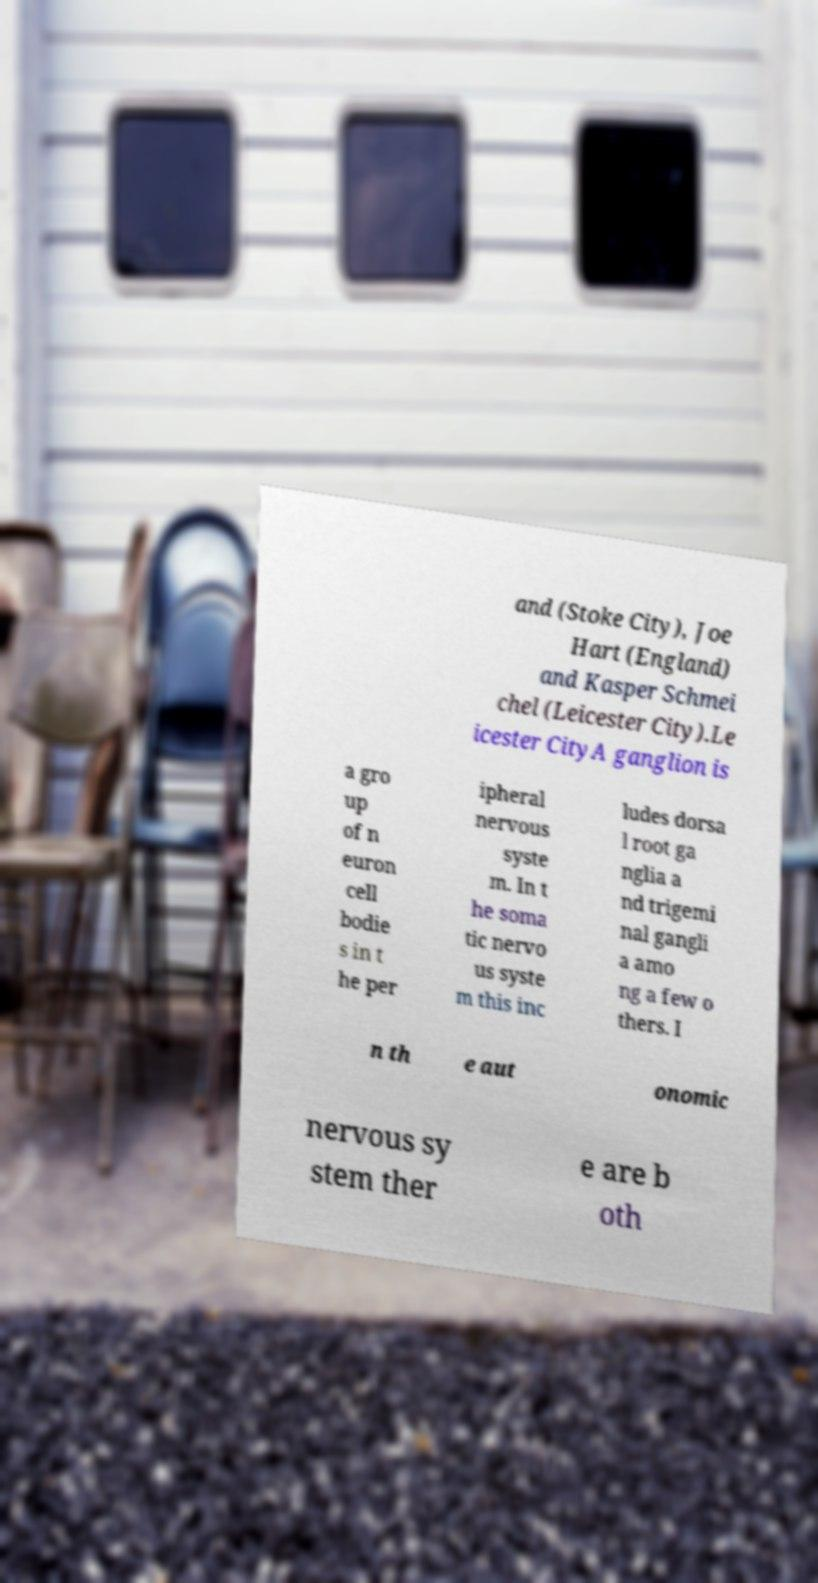For documentation purposes, I need the text within this image transcribed. Could you provide that? and (Stoke City), Joe Hart (England) and Kasper Schmei chel (Leicester City).Le icester CityA ganglion is a gro up of n euron cell bodie s in t he per ipheral nervous syste m. In t he soma tic nervo us syste m this inc ludes dorsa l root ga nglia a nd trigemi nal gangli a amo ng a few o thers. I n th e aut onomic nervous sy stem ther e are b oth 